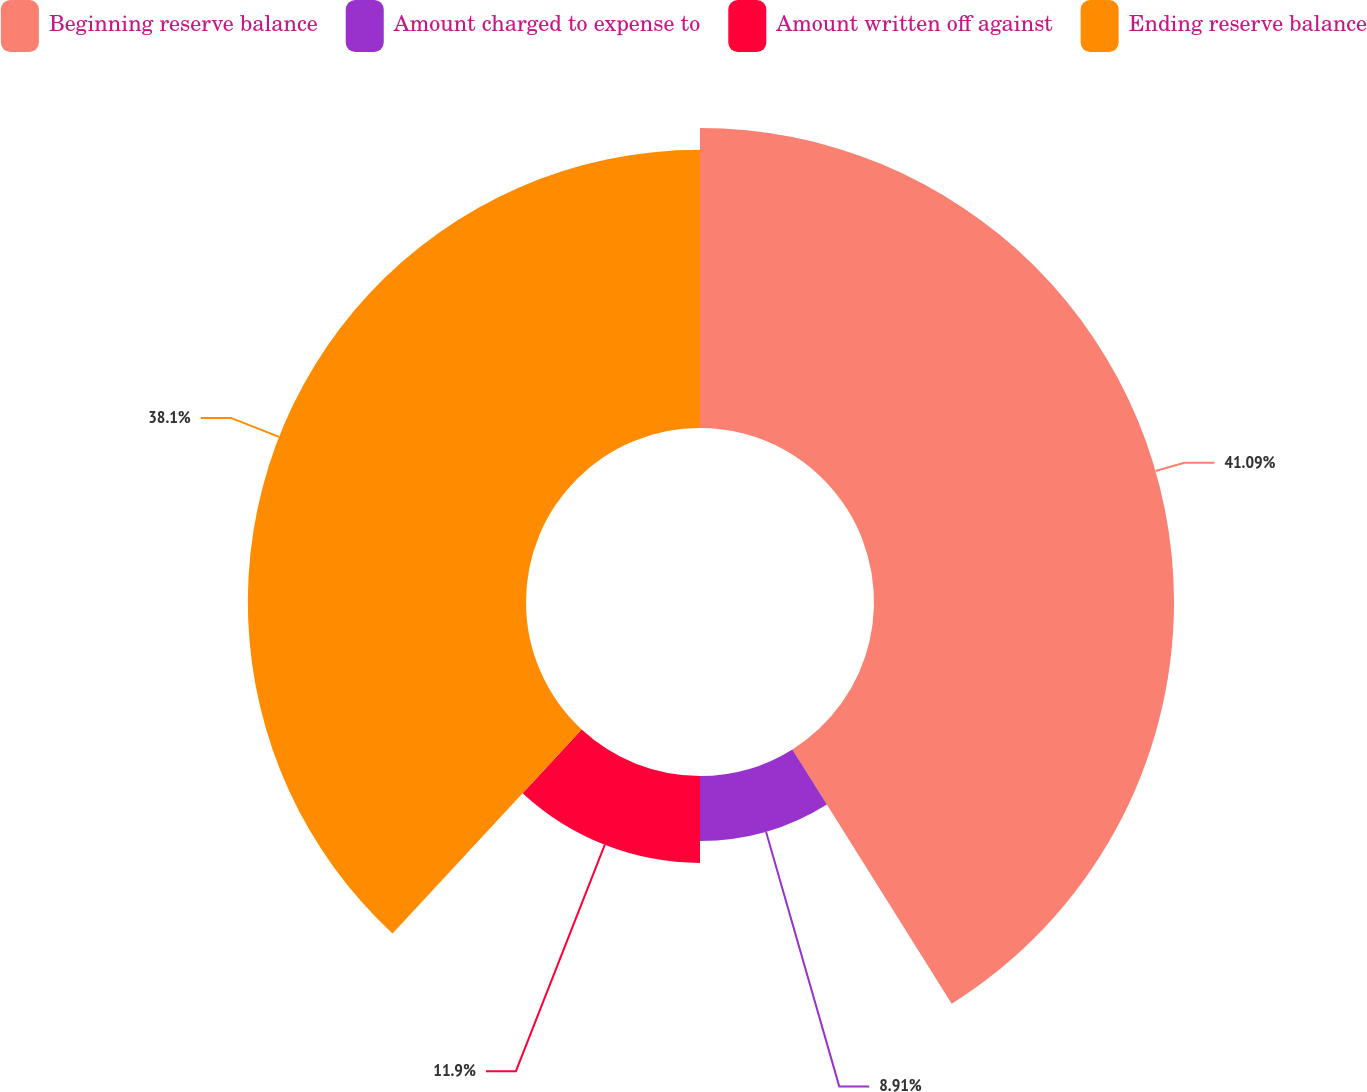Convert chart. <chart><loc_0><loc_0><loc_500><loc_500><pie_chart><fcel>Beginning reserve balance<fcel>Amount charged to expense to<fcel>Amount written off against<fcel>Ending reserve balance<nl><fcel>41.09%<fcel>8.91%<fcel>11.9%<fcel>38.1%<nl></chart> 